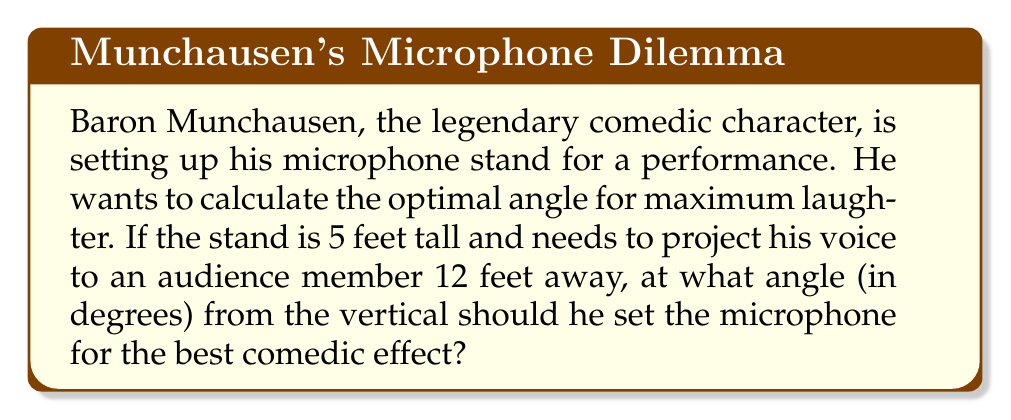Teach me how to tackle this problem. Let's approach this step-by-step using trigonometry:

1) First, let's visualize the problem:
   [asy]
   import geometry;
   size(200);
   pair A=(0,0), B=(0,5), C=(12,0);
   draw(A--B--C--A);
   draw(B--(0,5.5),arrow=Arrow(TeXHead));
   label("5 ft",B--A,W);
   label("12 ft",A--C,S);
   label("θ",B,NE);
   [/asy]

2) We have a right triangle where:
   - The vertical side (microphone stand) is 5 feet
   - The horizontal distance to the audience member is 12 feet
   - We need to find the angle θ from the vertical

3) We can use the arctangent function to find this angle:

   $$\theta = \arctan(\frac{\text{opposite}}{\text{adjacent}})$$

4) In this case:
   - Opposite = 12 feet (horizontal distance)
   - Adjacent = 5 feet (microphone stand height)

5) Plugging these values into our equation:

   $$\theta = \arctan(\frac{12}{5})$$

6) Using a calculator or computer:

   $$\theta \approx 67.38\text{ degrees}$$

7) However, this is the angle from the horizontal. The question asks for the angle from the vertical, which is the complement of this angle:

   $$90^\circ - 67.38^\circ \approx 22.62^\circ$$

8) Rounding to two decimal places for precision:

   $$\theta \approx 22.62^\circ$$
Answer: $22.62^\circ$ 